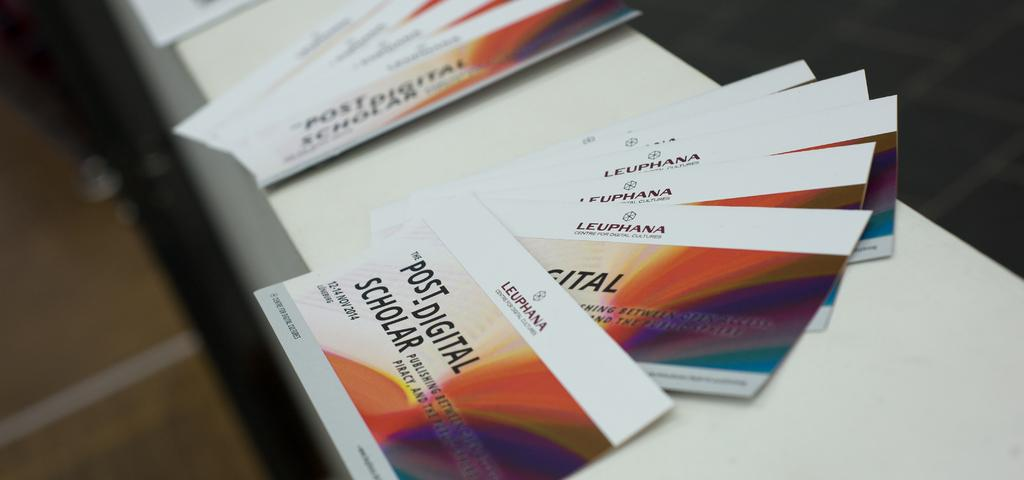Provide a one-sentence caption for the provided image. A few business cards that say Leuphana Post-. 